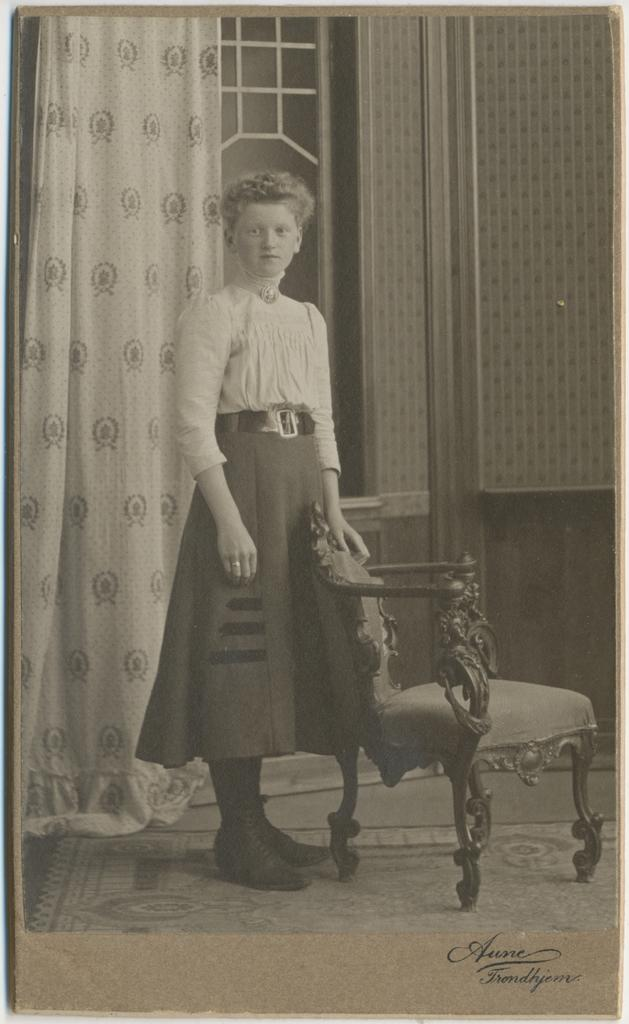What type of image is this? The image is a black and white photograph. Can you describe the person in the image? There is a person standing in the image. What is the person holding? The person is holding a chair. What can be seen in the background of the image? There are curtains and windows in the background of the image. What grade did the person in the image receive for their performance? There is no information about a performance or grade in the image, as it only shows a person standing and holding a chair. Who is the manager of the person in the image? There is no information about a manager or any professional context in the image. 